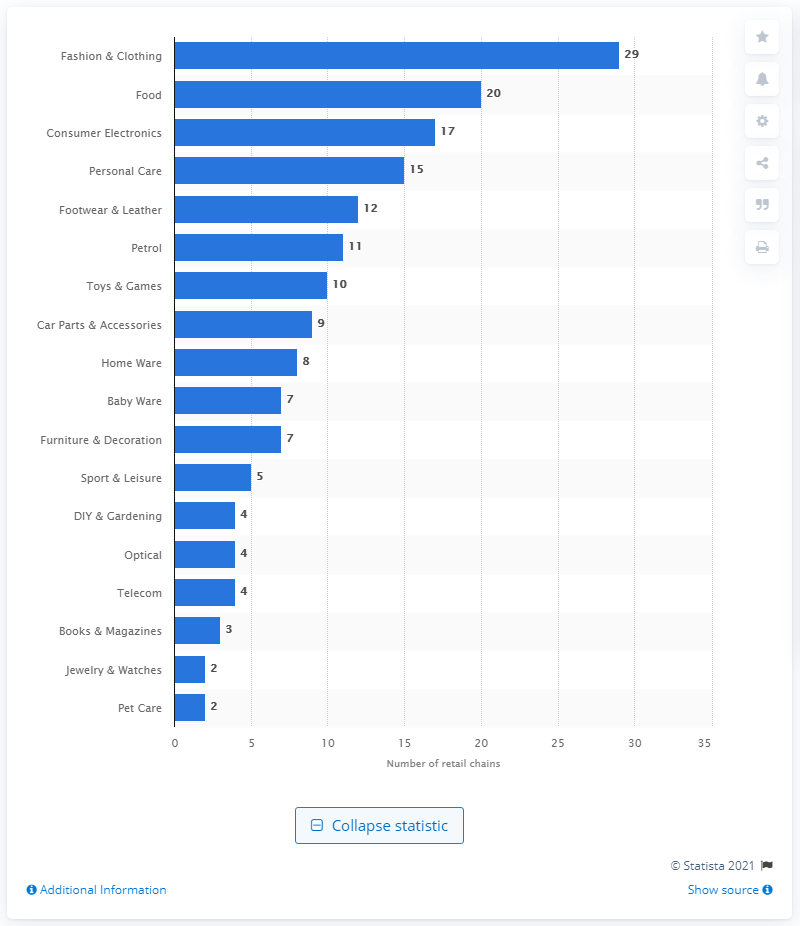Give some essential details in this illustration. The food sector ranked second by having 20 retail chains. There were 29 retail chains in the fashion and clothing industry in Greece in 2020. 